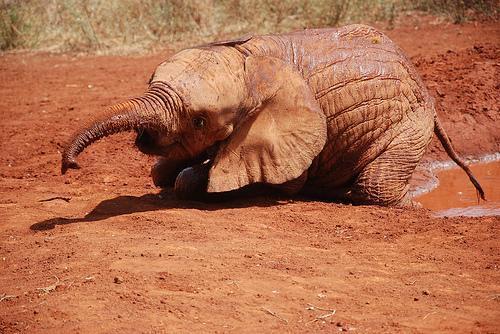How many elephants?
Give a very brief answer. 1. 